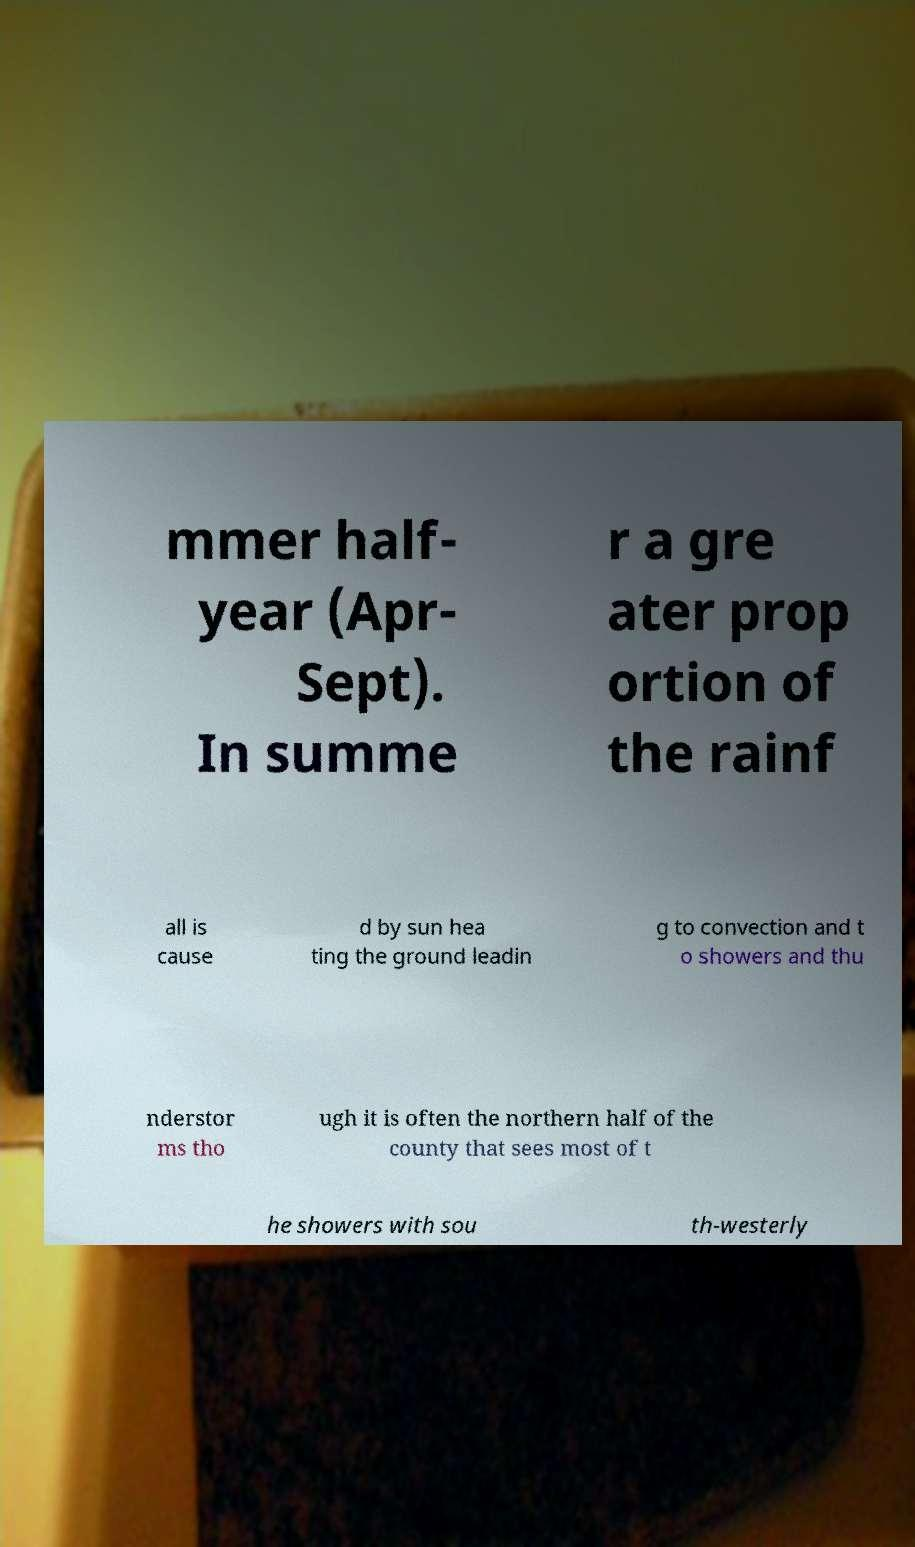Can you read and provide the text displayed in the image?This photo seems to have some interesting text. Can you extract and type it out for me? mmer half- year (Apr- Sept). In summe r a gre ater prop ortion of the rainf all is cause d by sun hea ting the ground leadin g to convection and t o showers and thu nderstor ms tho ugh it is often the northern half of the county that sees most of t he showers with sou th-westerly 